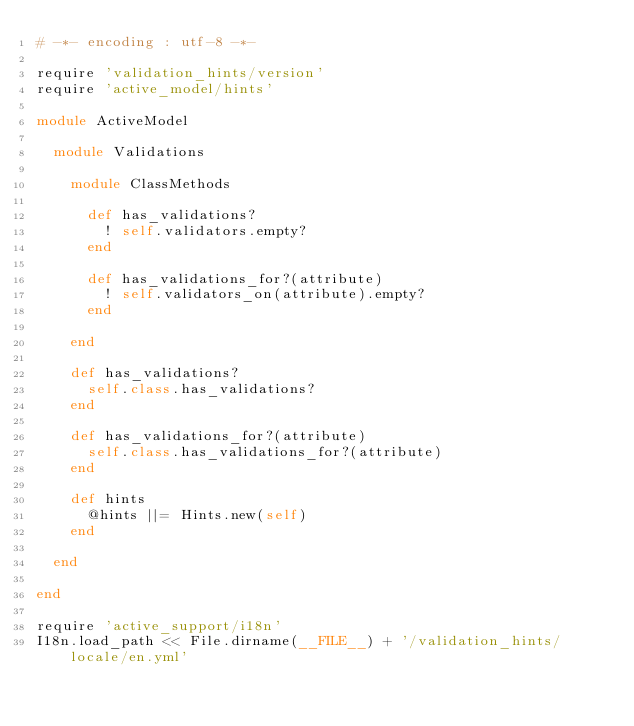Convert code to text. <code><loc_0><loc_0><loc_500><loc_500><_Ruby_># -*- encoding : utf-8 -*-

require 'validation_hints/version'
require 'active_model/hints'

module ActiveModel

  module Validations

    module ClassMethods

      def has_validations?
        ! self.validators.empty?
      end

      def has_validations_for?(attribute)
        ! self.validators_on(attribute).empty?
      end

    end

    def has_validations?
      self.class.has_validations?
    end

    def has_validations_for?(attribute)
      self.class.has_validations_for?(attribute)
    end

    def hints
      @hints ||= Hints.new(self)
    end

  end

end

require 'active_support/i18n'
I18n.load_path << File.dirname(__FILE__) + '/validation_hints/locale/en.yml'
</code> 